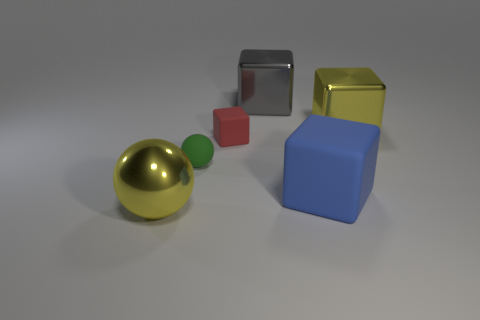Subtract all cyan cubes. Subtract all gray balls. How many cubes are left? 4 Add 1 small red matte cylinders. How many objects exist? 7 Subtract all blocks. How many objects are left? 2 Add 3 blue cubes. How many blue cubes are left? 4 Add 1 gray things. How many gray things exist? 2 Subtract 0 red spheres. How many objects are left? 6 Subtract all blue spheres. Subtract all large shiny objects. How many objects are left? 3 